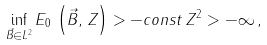Convert formula to latex. <formula><loc_0><loc_0><loc_500><loc_500>\inf _ { \vec { B } \in L ^ { 2 } } E _ { 0 } \, \left ( \vec { B } , \, Z \right ) > - c o n s t \, Z ^ { 2 } > - \infty \, ,</formula> 